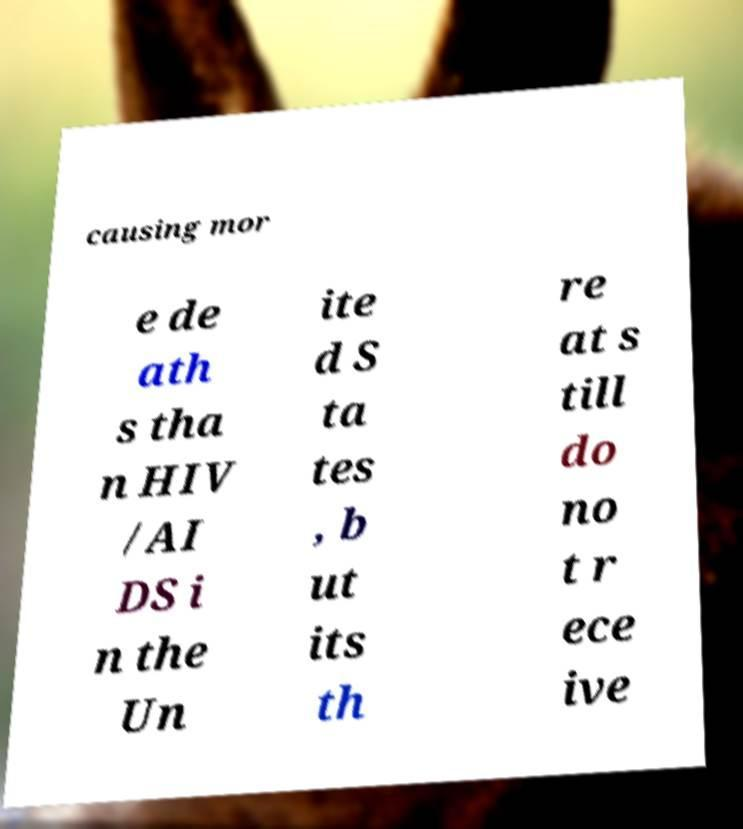Please read and relay the text visible in this image. What does it say? causing mor e de ath s tha n HIV /AI DS i n the Un ite d S ta tes , b ut its th re at s till do no t r ece ive 